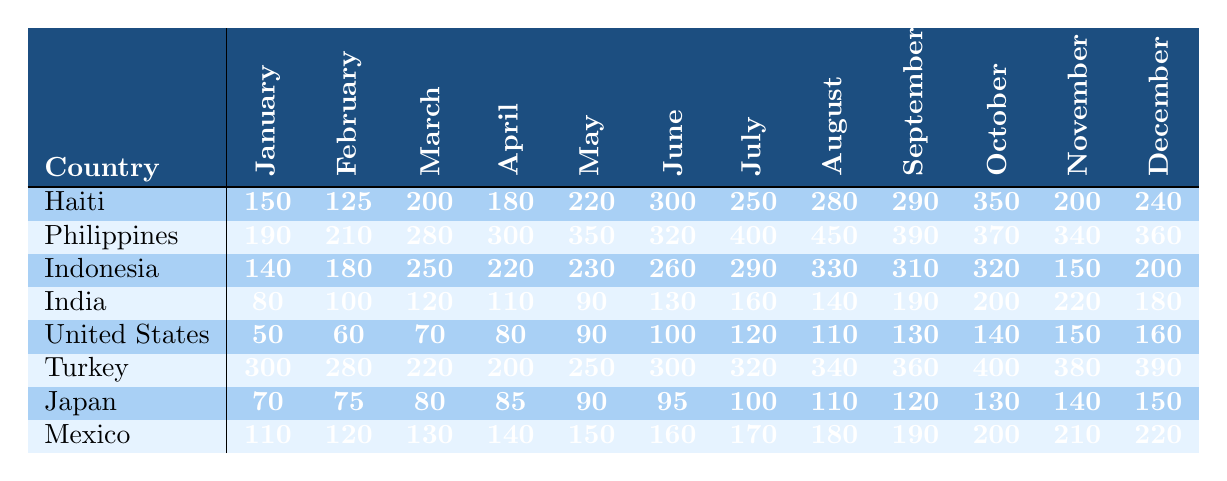What was the highest number of volunteers deployed in a single month in Haiti during 2023? Looking through the values for Haiti, the highest number appears in June with 300 volunteers.
Answer: 300 Which country had the most volunteers in July 2023? In July, the country with the highest number of volunteers is the Philippines, with 400 volunteers.
Answer: Philippines What is the total number of volunteers deployed in Turkey throughout 2023? Adding up Turkey's monthly values: 300 + 280 + 220 + 200 + 250 + 300 + 320 + 340 + 360 + 400 + 380 + 390 equals 3,640.
Answer: 3640 In which month did India have the least number of volunteers? By looking at India's monthly values, January has the lowest number of volunteers, with only 80.
Answer: January What was the average number of volunteers deployed by Japan in 2023? Summing Japan's deployments gives: 70 + 75 + 80 + 85 + 90 + 95 + 100 + 110 + 120 + 130 + 140 + 150 = 1,270. Dividing that by 12 months results in an average of approximately 105.83.
Answer: 105.83 Did the United States have more volunteers deployed in November or December 2023? In November, the United States had 150 volunteers, and in December it had 160. Therefore, December had more volunteers.
Answer: Yes How many more volunteers were deployed in August compared to January in the Philippines? The number of volunteers in August is 450, and in January is 190. The difference is 450 - 190 = 260.
Answer: 260 Which country had a decrease in volunteer deployment from August to September? In Indonesia, the volunteers decreased from 330 in August to 310 in September, showing a decline of 20 volunteers.
Answer: Indonesia What are the total volunteer deployments for Mexico in the last quarter of 2023 (October to December)? Summing the values from October to December: 200 + 210 + 220 gives a total of 630 volunteers deployed in that period.
Answer: 630 Which month had the least overall volunteer deployments across all countries? After analyzing the monthly totals, January has the lowest overall deployment with 1,379 volunteers when summed across all countries.
Answer: January In which month did Turkey experience its highest deployment, and how many were deployed? In October, Turkey had the highest deployment with 400 volunteers.
Answer: October, 400 